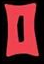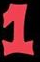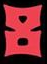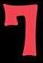What words are shown in these images in order, separated by a semicolon? 0; 1; 8; 7 